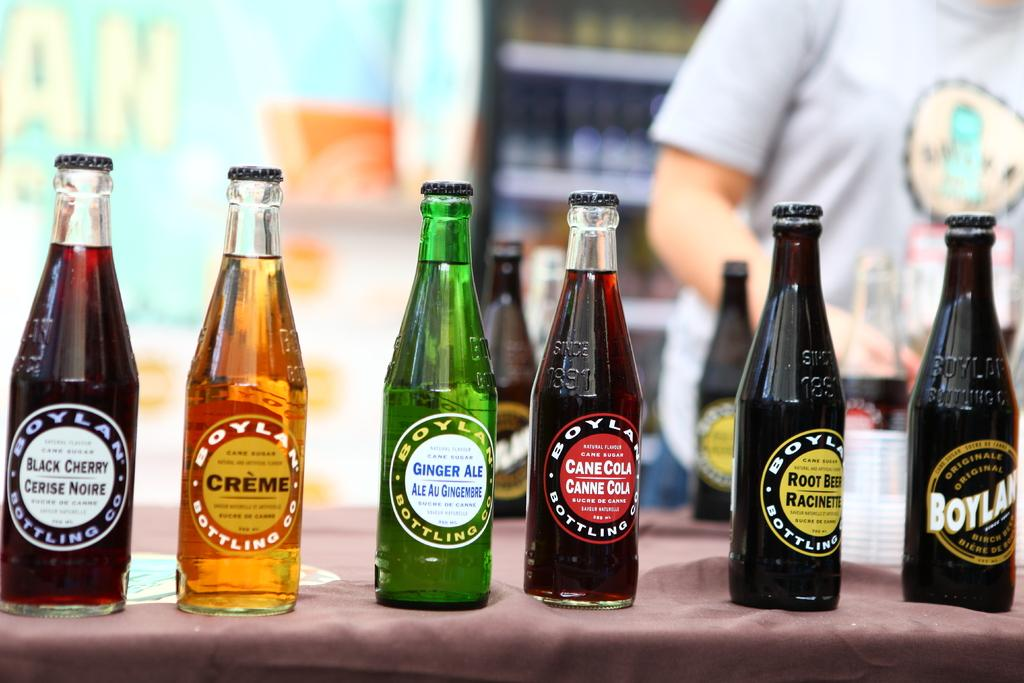<image>
Describe the image concisely. Several bottled beverages, made by Boyla, are lined up and include black cherry and ginger ale. 